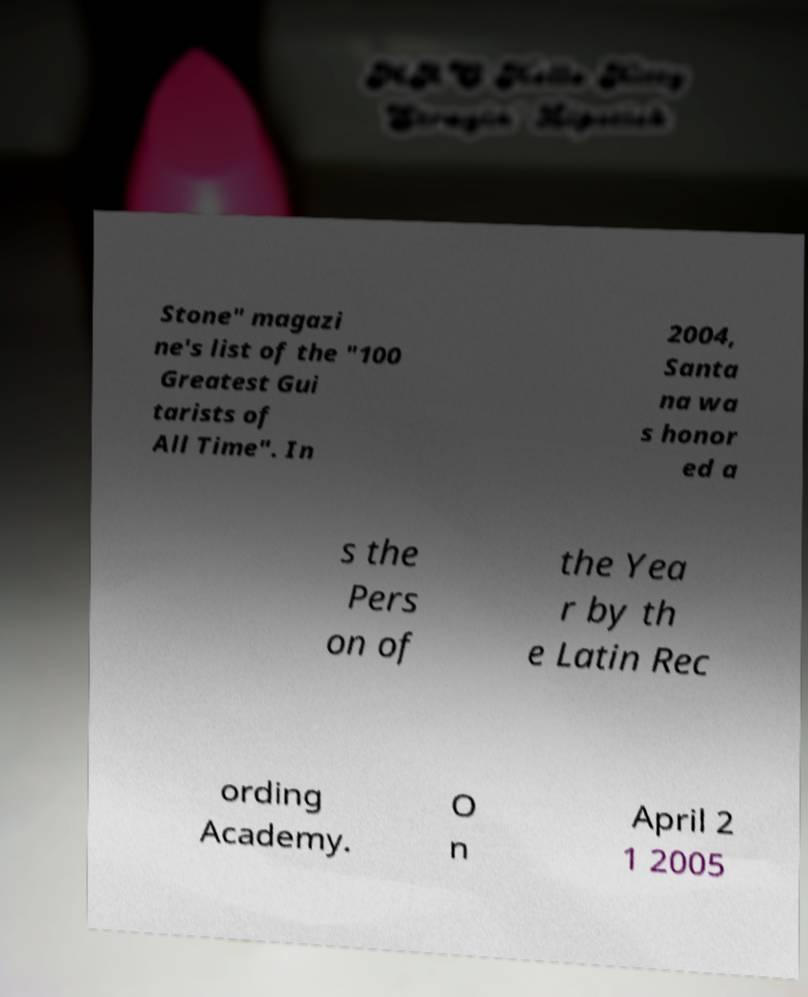I need the written content from this picture converted into text. Can you do that? Stone" magazi ne's list of the "100 Greatest Gui tarists of All Time". In 2004, Santa na wa s honor ed a s the Pers on of the Yea r by th e Latin Rec ording Academy. O n April 2 1 2005 